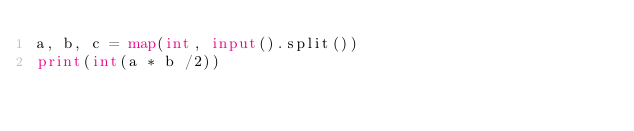Convert code to text. <code><loc_0><loc_0><loc_500><loc_500><_Python_>a, b, c = map(int, input().split())
print(int(a * b /2))</code> 